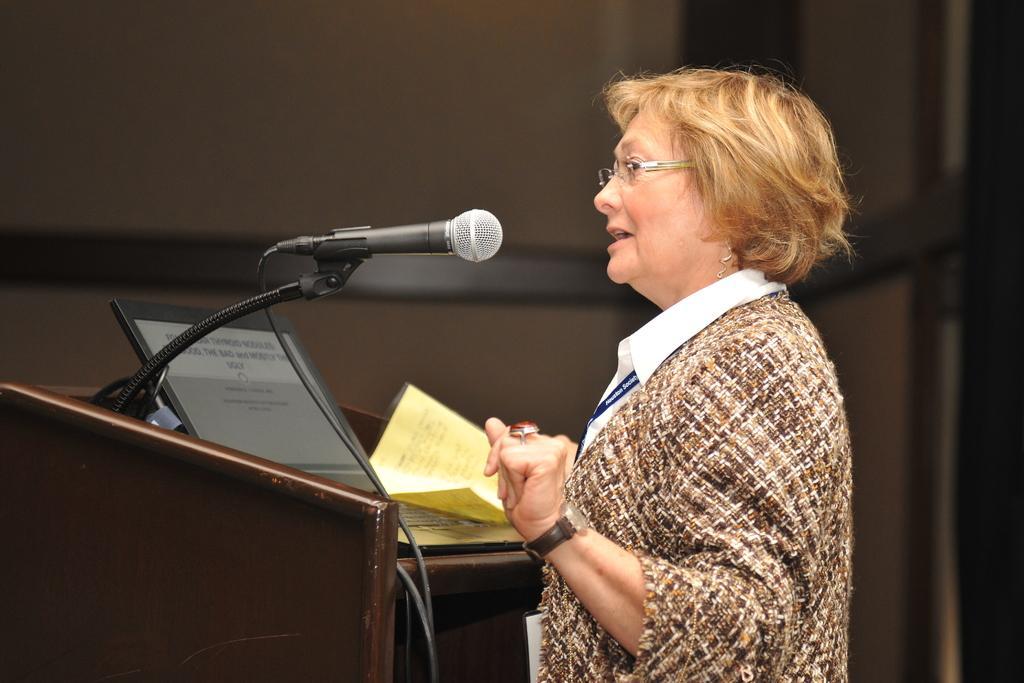Please provide a concise description of this image. In this image we can see a woman standing at the podium. On the podium there are papers, laptop and a mic attached to it. 